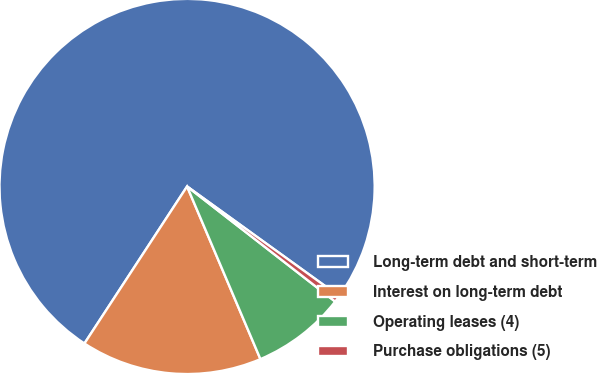Convert chart. <chart><loc_0><loc_0><loc_500><loc_500><pie_chart><fcel>Long-term debt and short-term<fcel>Interest on long-term debt<fcel>Operating leases (4)<fcel>Purchase obligations (5)<nl><fcel>75.73%<fcel>15.61%<fcel>8.09%<fcel>0.57%<nl></chart> 